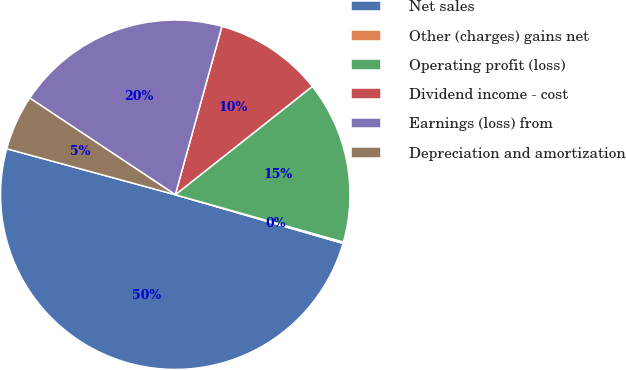Convert chart to OTSL. <chart><loc_0><loc_0><loc_500><loc_500><pie_chart><fcel>Net sales<fcel>Other (charges) gains net<fcel>Operating profit (loss)<fcel>Dividend income - cost<fcel>Earnings (loss) from<fcel>Depreciation and amortization<nl><fcel>49.74%<fcel>0.13%<fcel>15.01%<fcel>10.05%<fcel>19.97%<fcel>5.09%<nl></chart> 